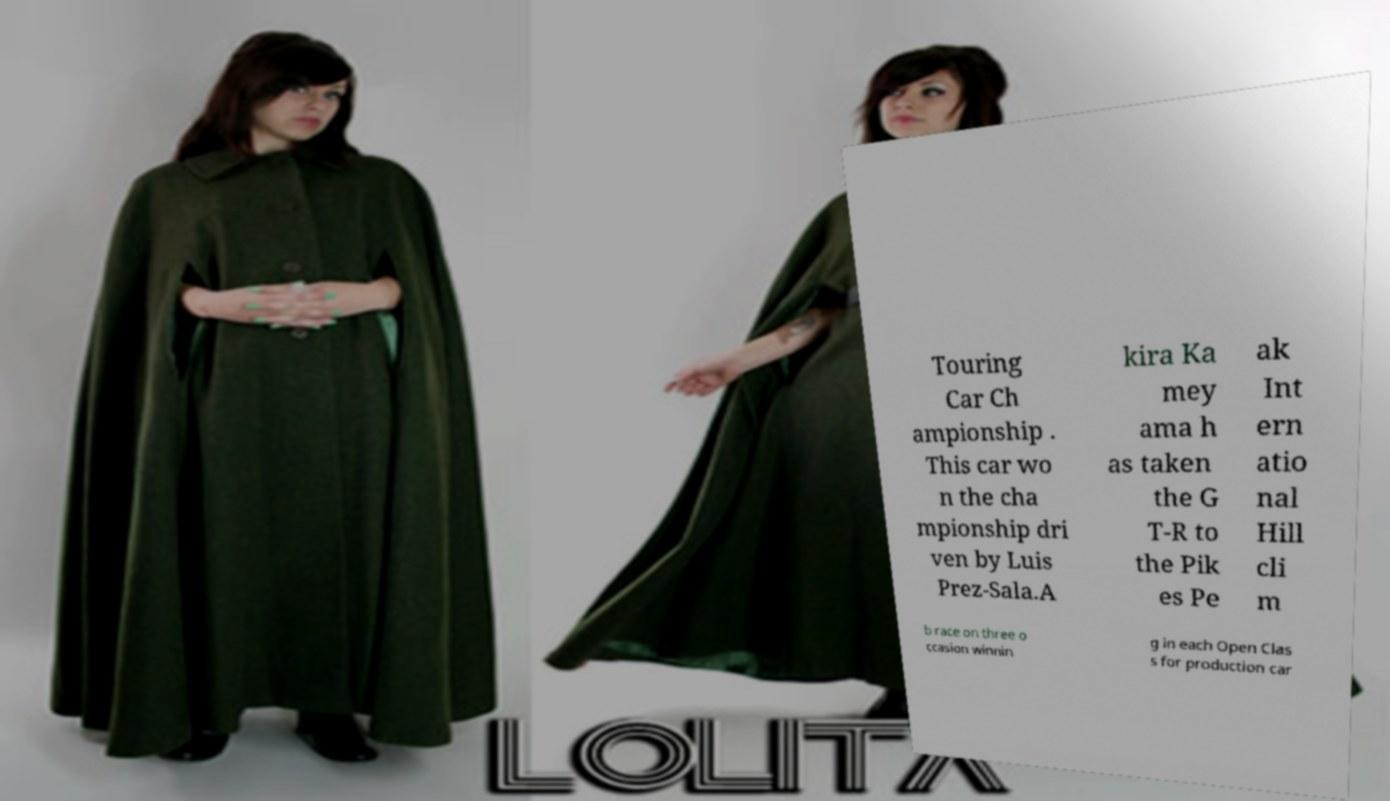For documentation purposes, I need the text within this image transcribed. Could you provide that? Touring Car Ch ampionship . This car wo n the cha mpionship dri ven by Luis Prez-Sala.A kira Ka mey ama h as taken the G T-R to the Pik es Pe ak Int ern atio nal Hill cli m b race on three o ccasion winnin g in each Open Clas s for production car 